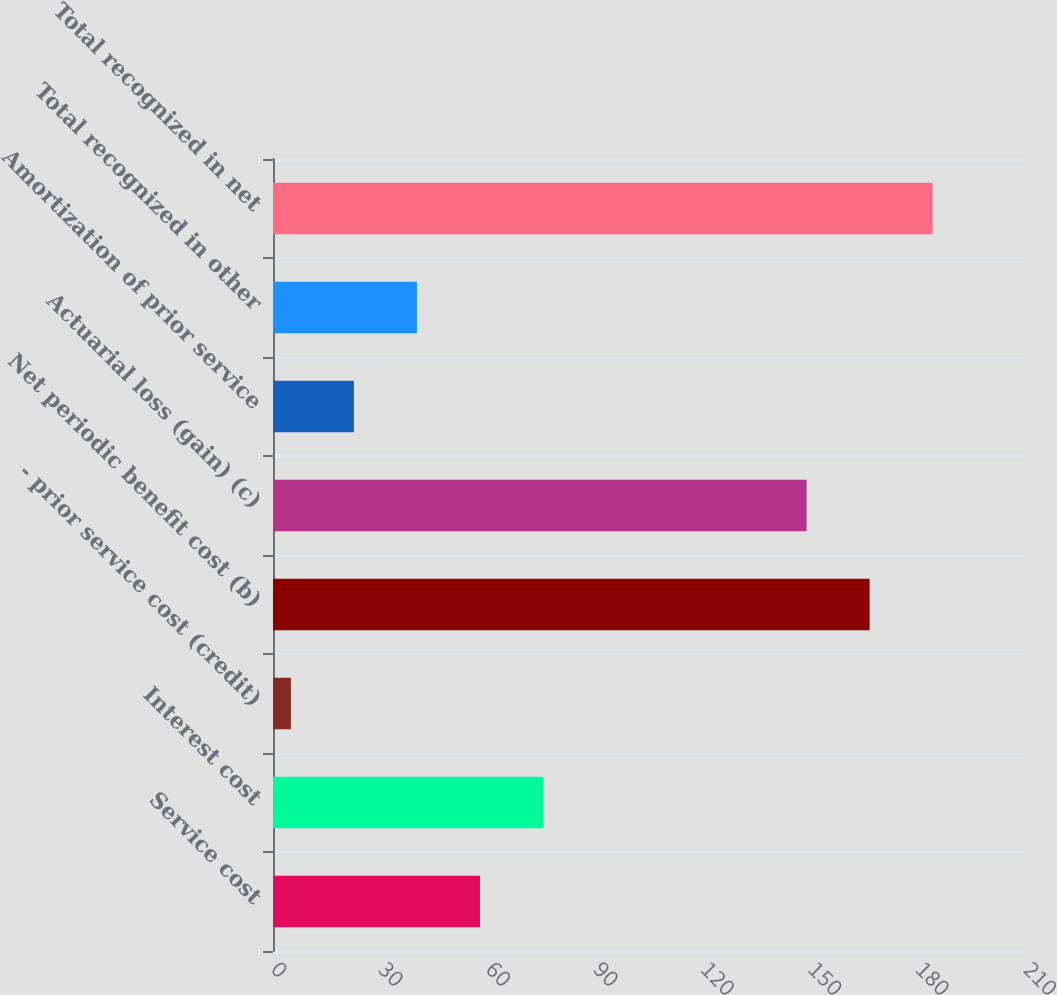<chart> <loc_0><loc_0><loc_500><loc_500><bar_chart><fcel>Service cost<fcel>Interest cost<fcel>- prior service cost (credit)<fcel>Net periodic benefit cost (b)<fcel>Actuarial loss (gain) (c)<fcel>Amortization of prior service<fcel>Total recognized in other<fcel>Total recognized in net<nl><fcel>57.8<fcel>75.4<fcel>5<fcel>166.6<fcel>149<fcel>22.6<fcel>40.2<fcel>184.2<nl></chart> 